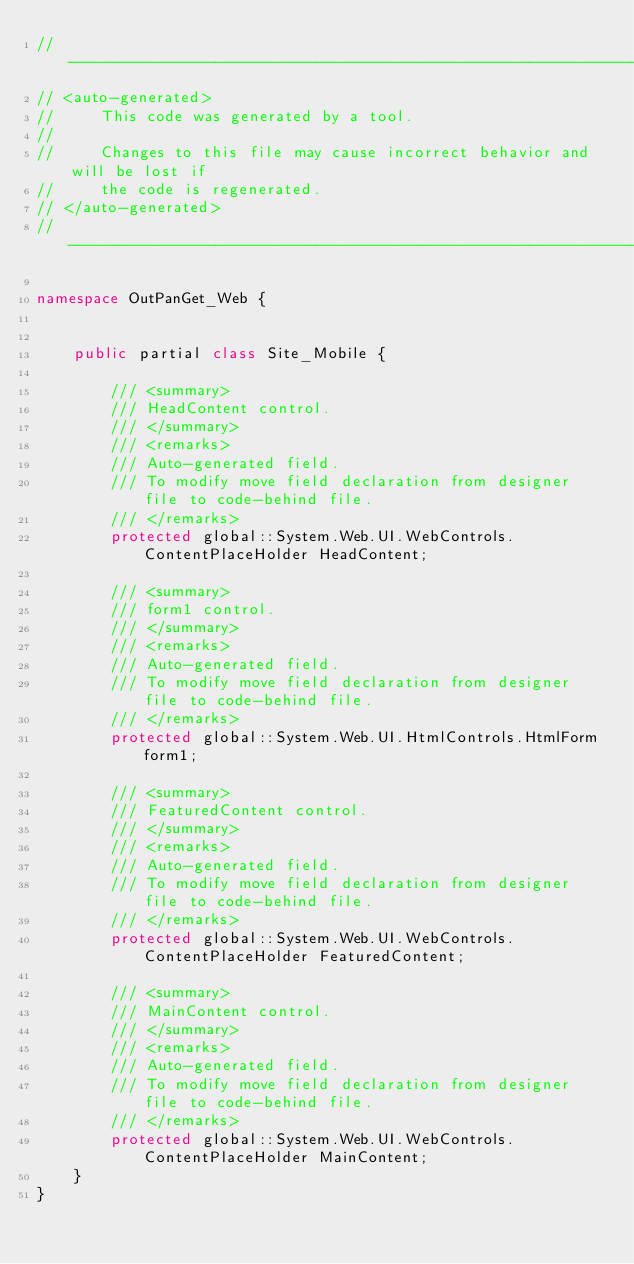<code> <loc_0><loc_0><loc_500><loc_500><_C#_>//------------------------------------------------------------------------------
// <auto-generated>
//     This code was generated by a tool.
//
//     Changes to this file may cause incorrect behavior and will be lost if
//     the code is regenerated. 
// </auto-generated>
//------------------------------------------------------------------------------

namespace OutPanGet_Web {
    
    
    public partial class Site_Mobile {
        
        /// <summary>
        /// HeadContent control.
        /// </summary>
        /// <remarks>
        /// Auto-generated field.
        /// To modify move field declaration from designer file to code-behind file.
        /// </remarks>
        protected global::System.Web.UI.WebControls.ContentPlaceHolder HeadContent;
        
        /// <summary>
        /// form1 control.
        /// </summary>
        /// <remarks>
        /// Auto-generated field.
        /// To modify move field declaration from designer file to code-behind file.
        /// </remarks>
        protected global::System.Web.UI.HtmlControls.HtmlForm form1;
        
        /// <summary>
        /// FeaturedContent control.
        /// </summary>
        /// <remarks>
        /// Auto-generated field.
        /// To modify move field declaration from designer file to code-behind file.
        /// </remarks>
        protected global::System.Web.UI.WebControls.ContentPlaceHolder FeaturedContent;
        
        /// <summary>
        /// MainContent control.
        /// </summary>
        /// <remarks>
        /// Auto-generated field.
        /// To modify move field declaration from designer file to code-behind file.
        /// </remarks>
        protected global::System.Web.UI.WebControls.ContentPlaceHolder MainContent;
    }
}
</code> 